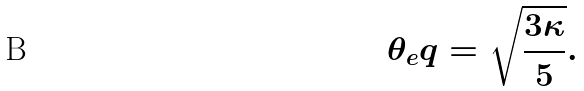Convert formula to latex. <formula><loc_0><loc_0><loc_500><loc_500>\theta _ { e } q = \sqrt { \frac { 3 \kappa } { 5 } } .</formula> 